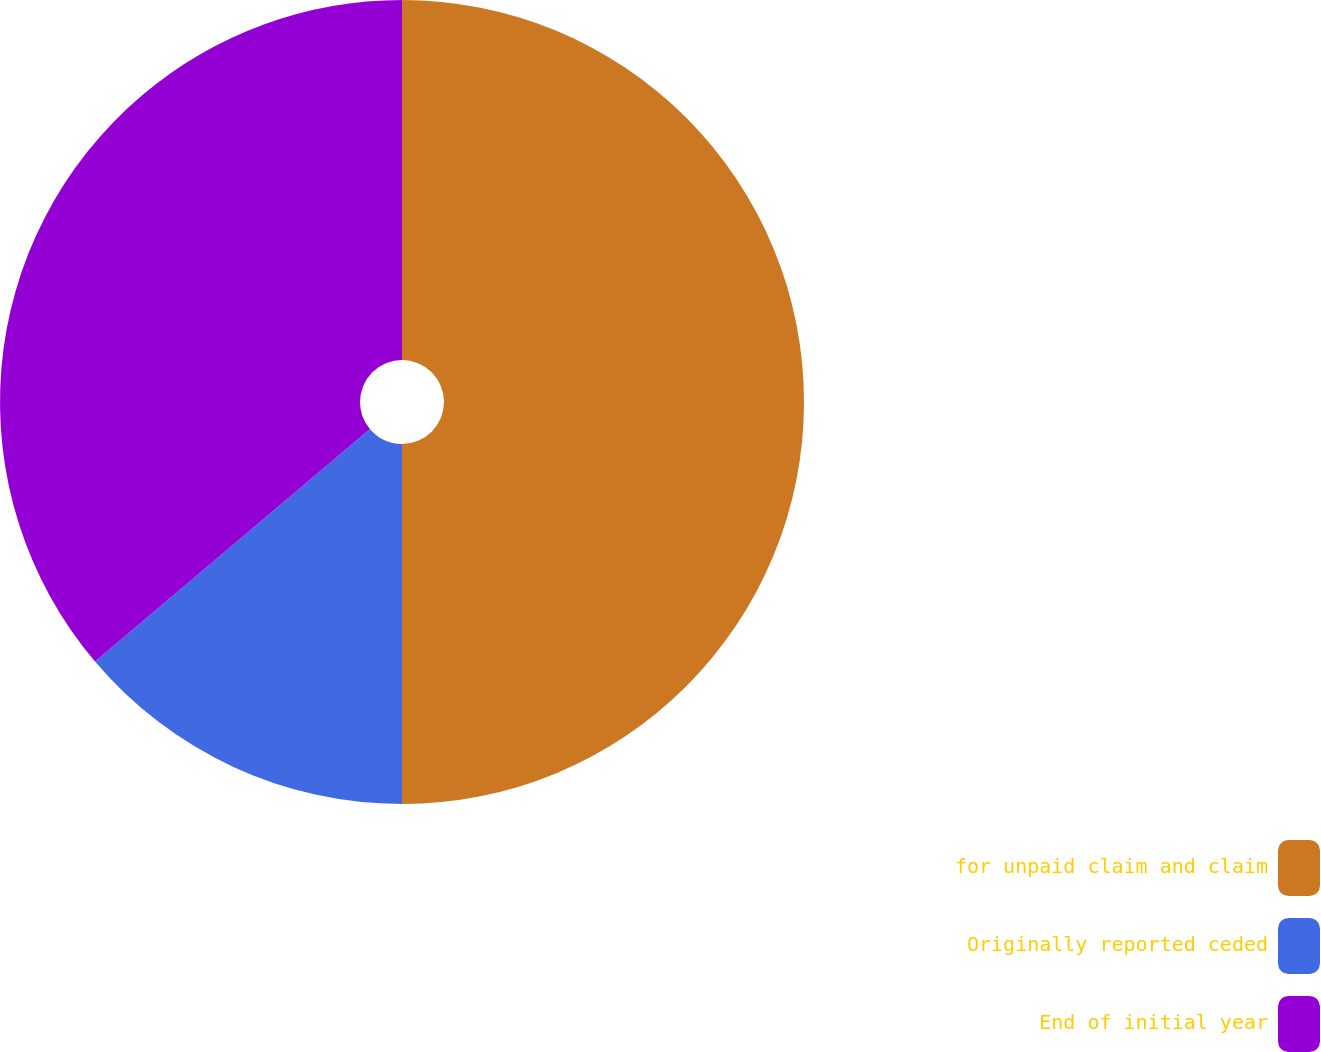Convert chart to OTSL. <chart><loc_0><loc_0><loc_500><loc_500><pie_chart><fcel>for unpaid claim and claim<fcel>Originally reported ceded<fcel>End of initial year<nl><fcel>50.0%<fcel>13.83%<fcel>36.17%<nl></chart> 